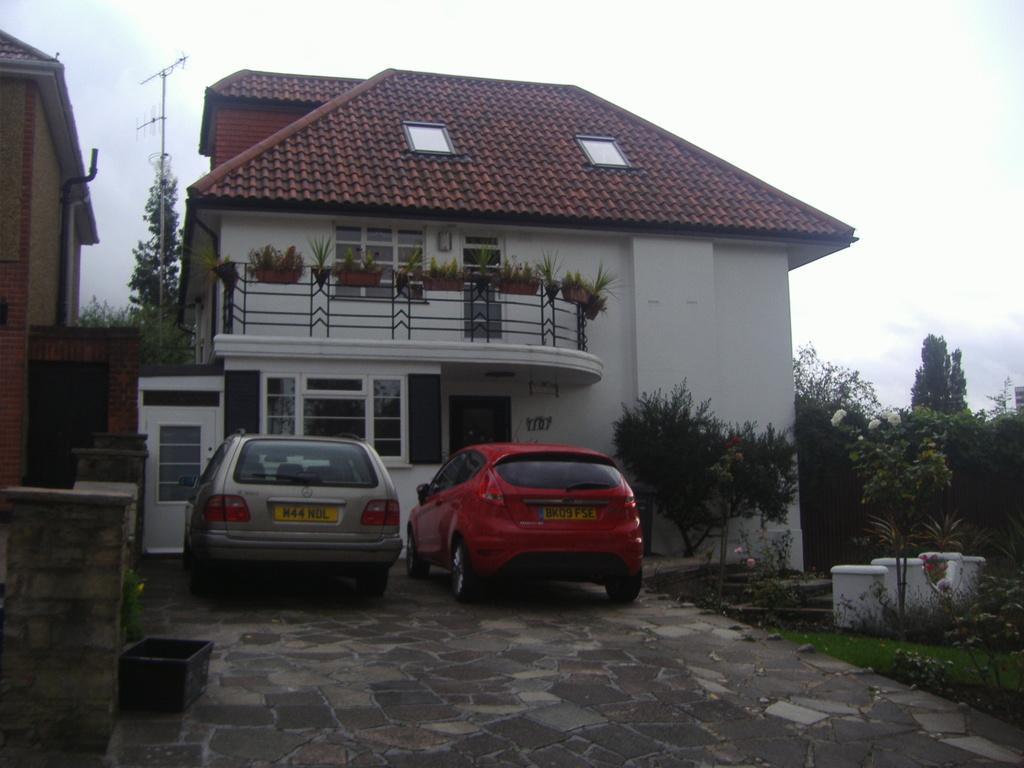How would you summarize this image in a sentence or two? In this image I can see there are buildings. And there are potted plants placed on the building. And in between the building there is a satellite. And in front there are cars on the ground and there is a tub. And at the side there are trees, Flowers and a marble on the grass. And at the top there is a sky. 